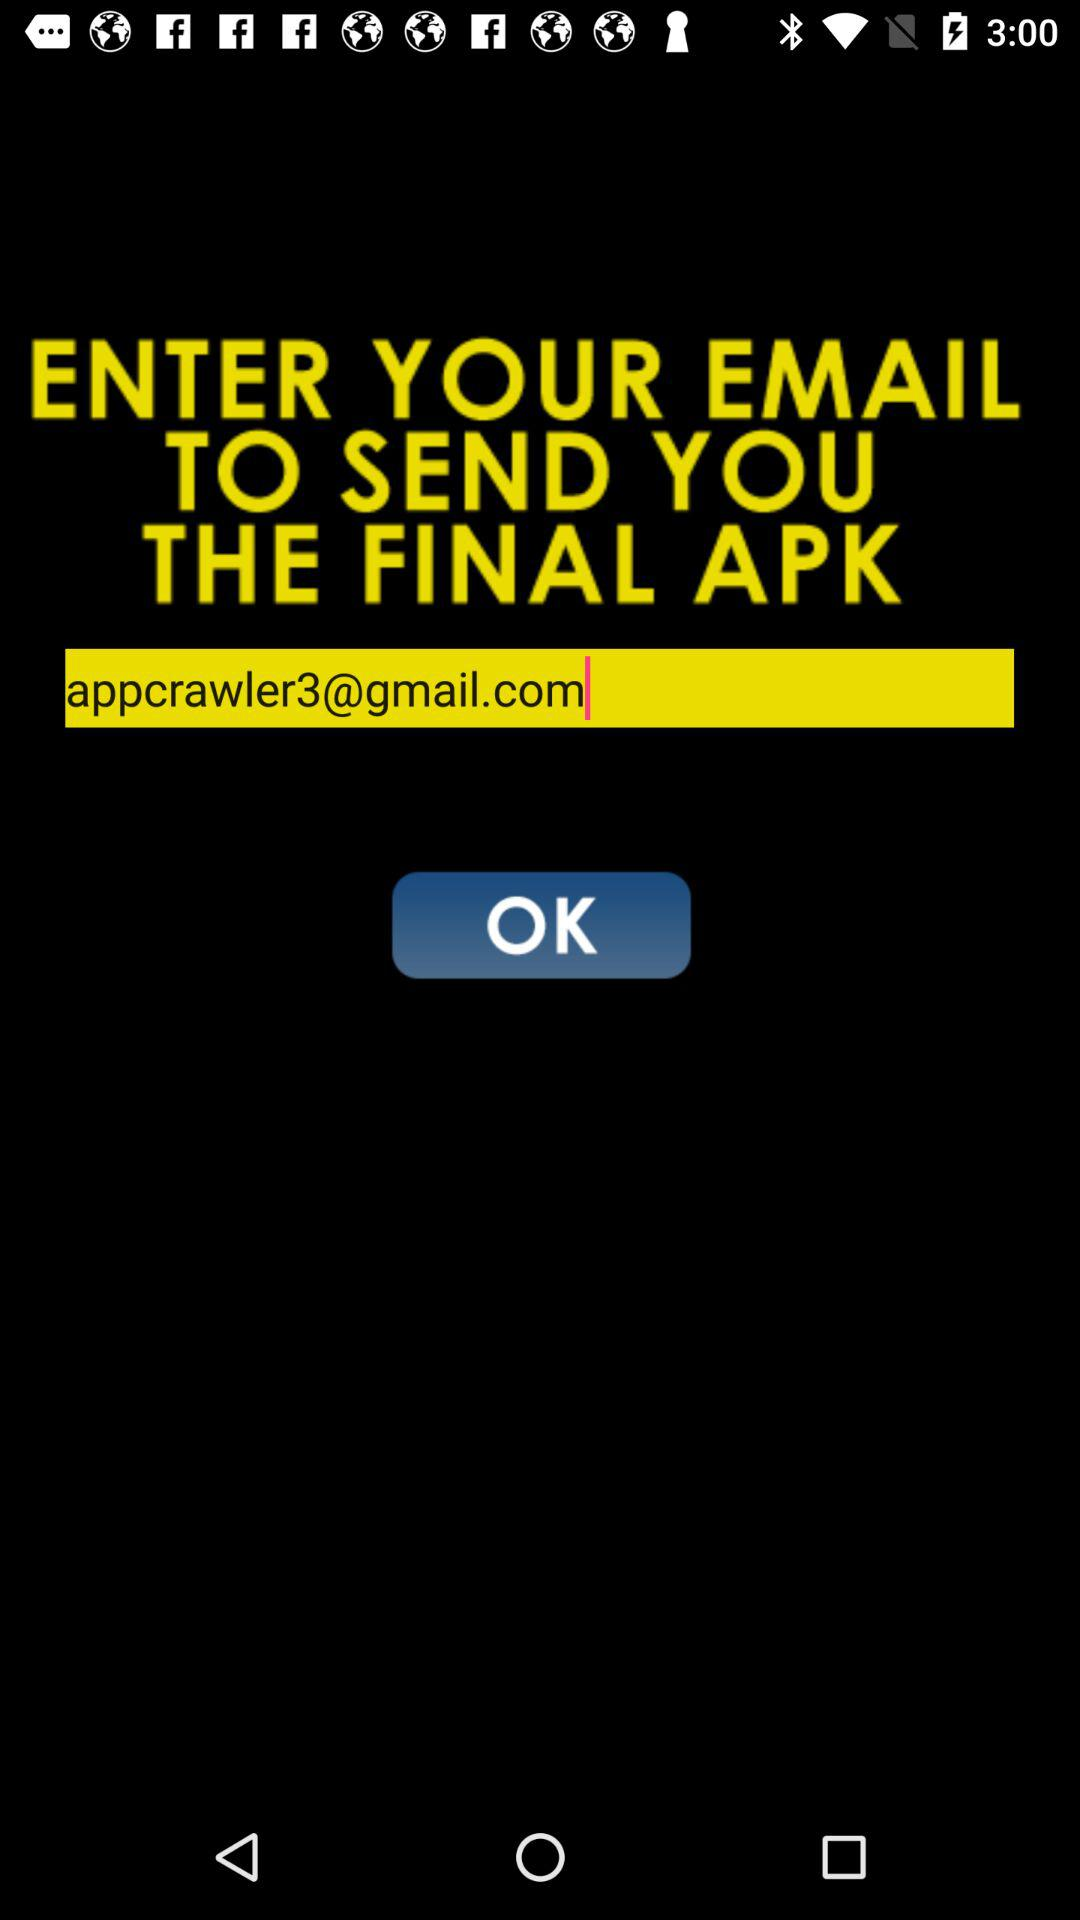What is the email address of the user? The email address is "appcrawler3@gmail.com". 